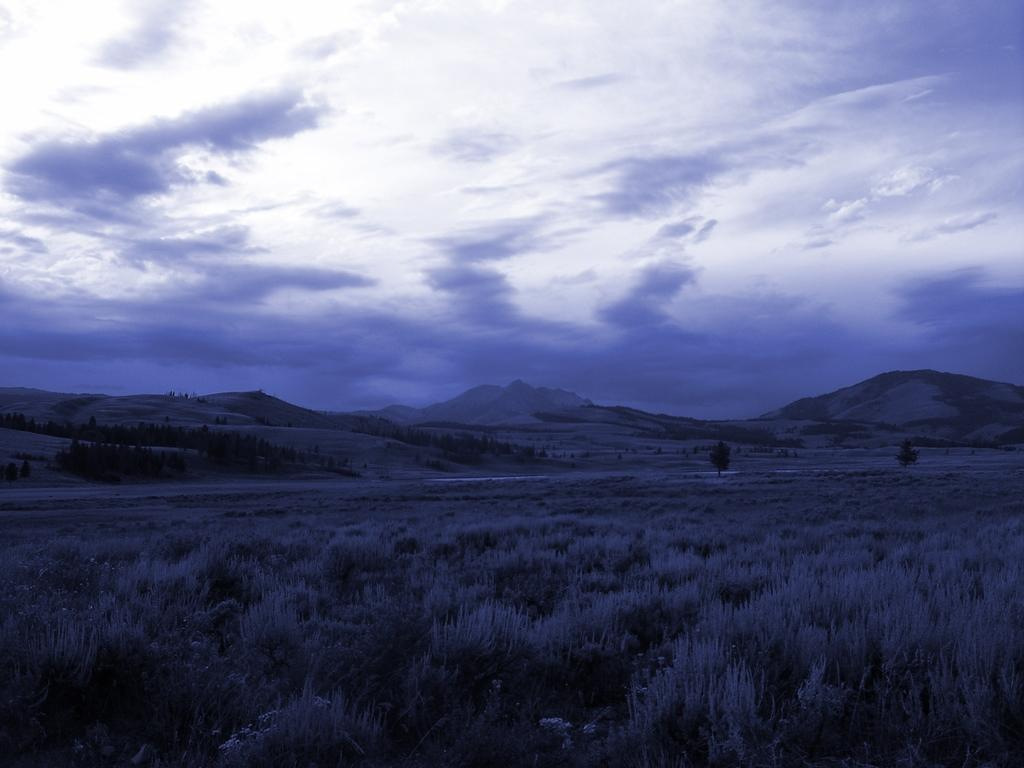What is the lighting condition in the image? The image is taken in the dark. What type of terrain can be seen in the image? There is grass visible in the image. What type of man-made structure is present in the image? There is a road in the image. What can be seen in the distance in the image? There are hills in the background of the image. What is visible in the sky in the image? The sky is visible in the background of the image, and clouds are present. What grade does the goat receive in the image? There is no goat present in the image, so it is not possible to determine a grade. What type of battle is depicted in the image? There is no battle depicted in the image; it features a dark landscape with grass, a road, hills, and a sky with clouds. 